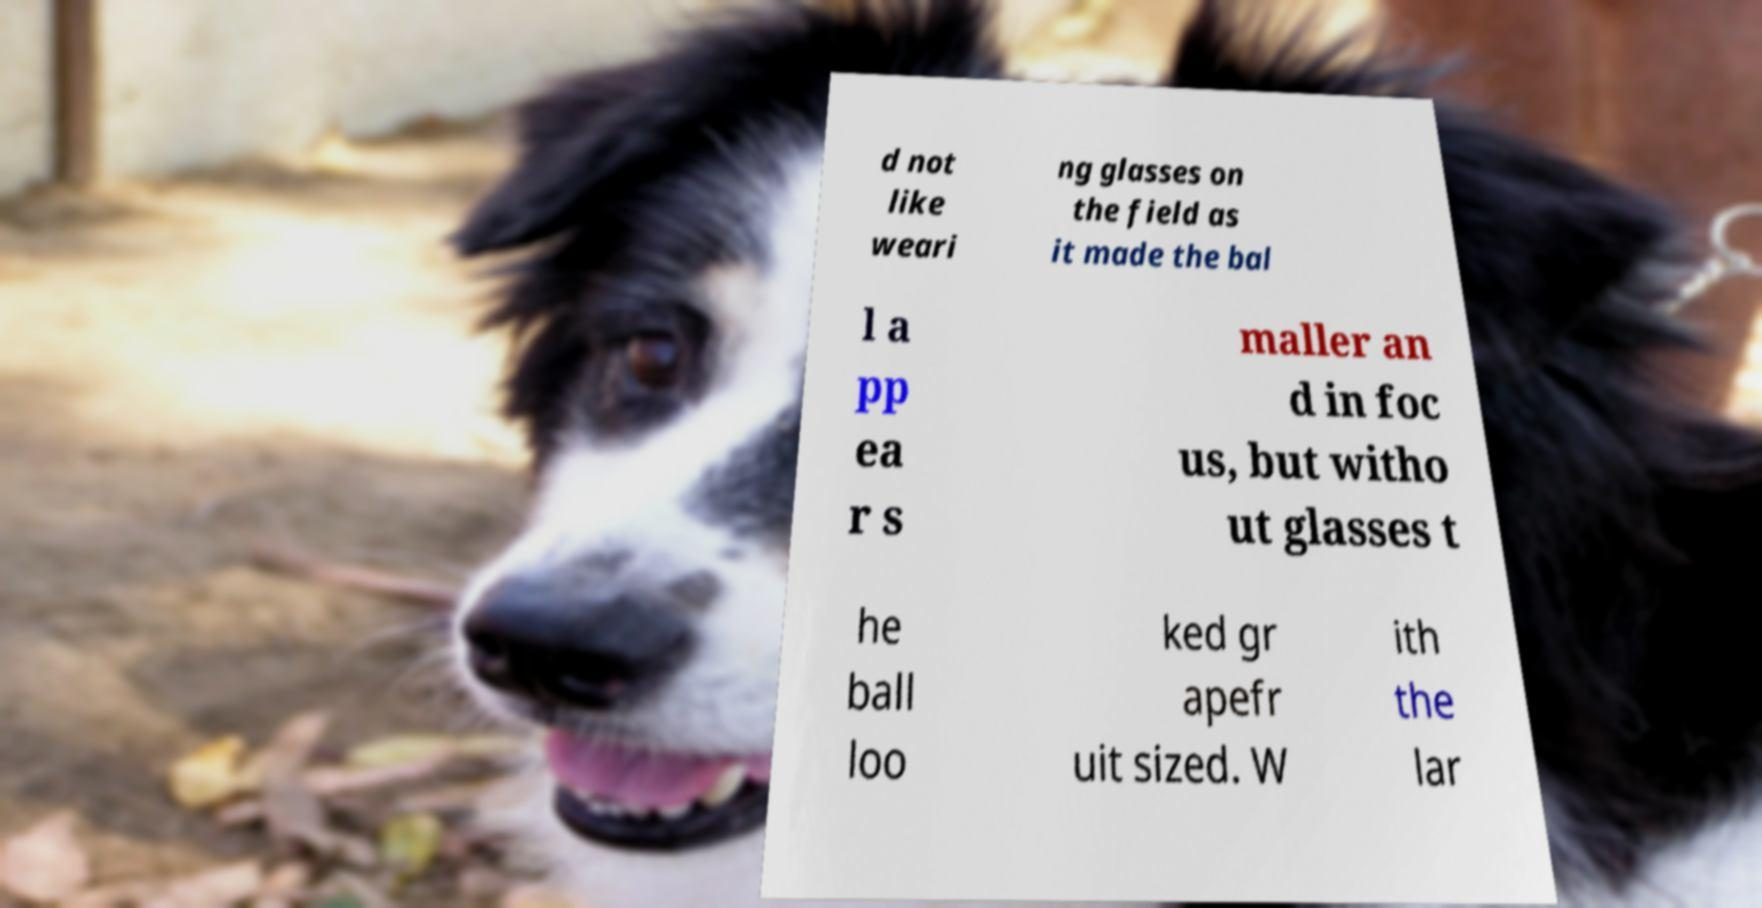What messages or text are displayed in this image? I need them in a readable, typed format. d not like weari ng glasses on the field as it made the bal l a pp ea r s maller an d in foc us, but witho ut glasses t he ball loo ked gr apefr uit sized. W ith the lar 